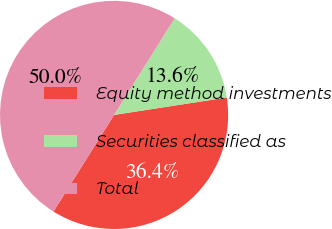Convert chart. <chart><loc_0><loc_0><loc_500><loc_500><pie_chart><fcel>Equity method investments<fcel>Securities classified as<fcel>Total<nl><fcel>36.36%<fcel>13.64%<fcel>50.0%<nl></chart> 